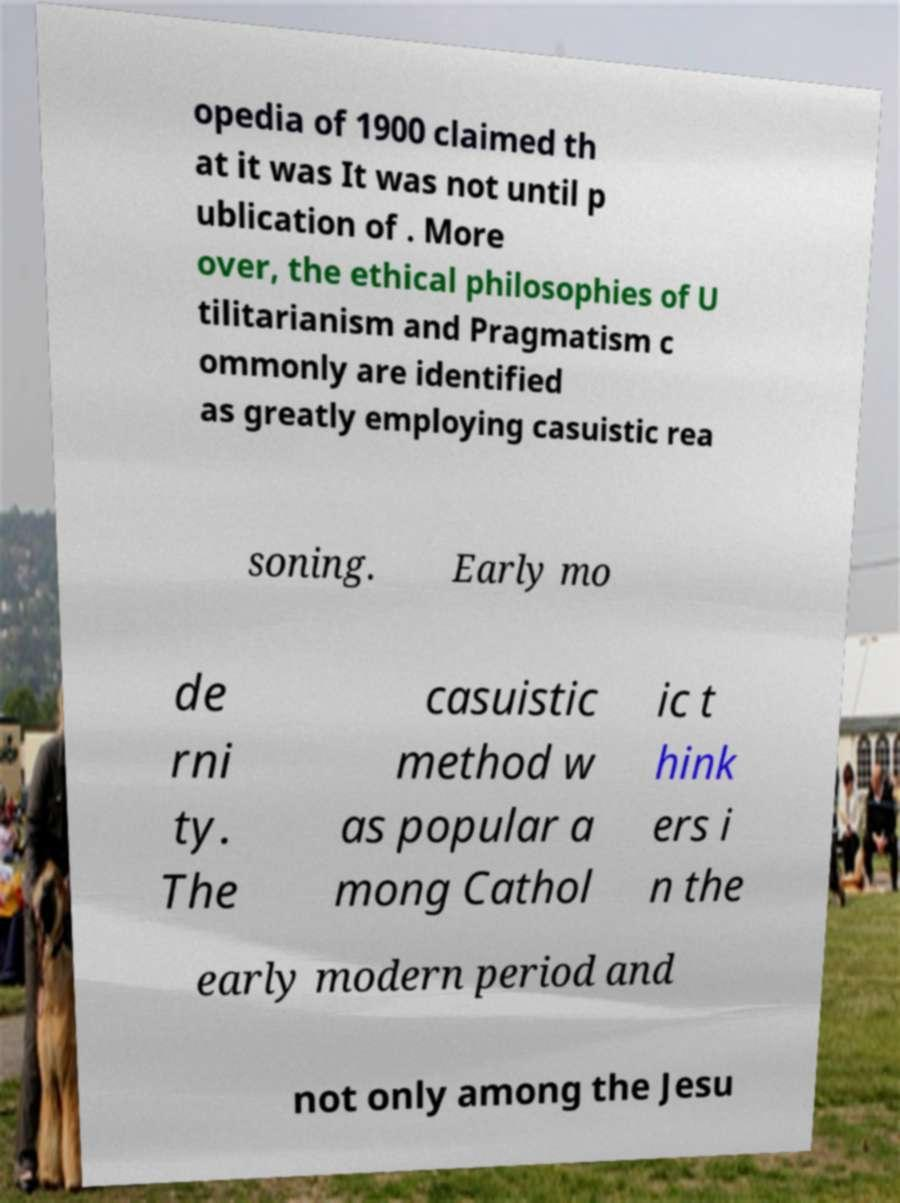Please identify and transcribe the text found in this image. opedia of 1900 claimed th at it was It was not until p ublication of . More over, the ethical philosophies of U tilitarianism and Pragmatism c ommonly are identified as greatly employing casuistic rea soning. Early mo de rni ty. The casuistic method w as popular a mong Cathol ic t hink ers i n the early modern period and not only among the Jesu 